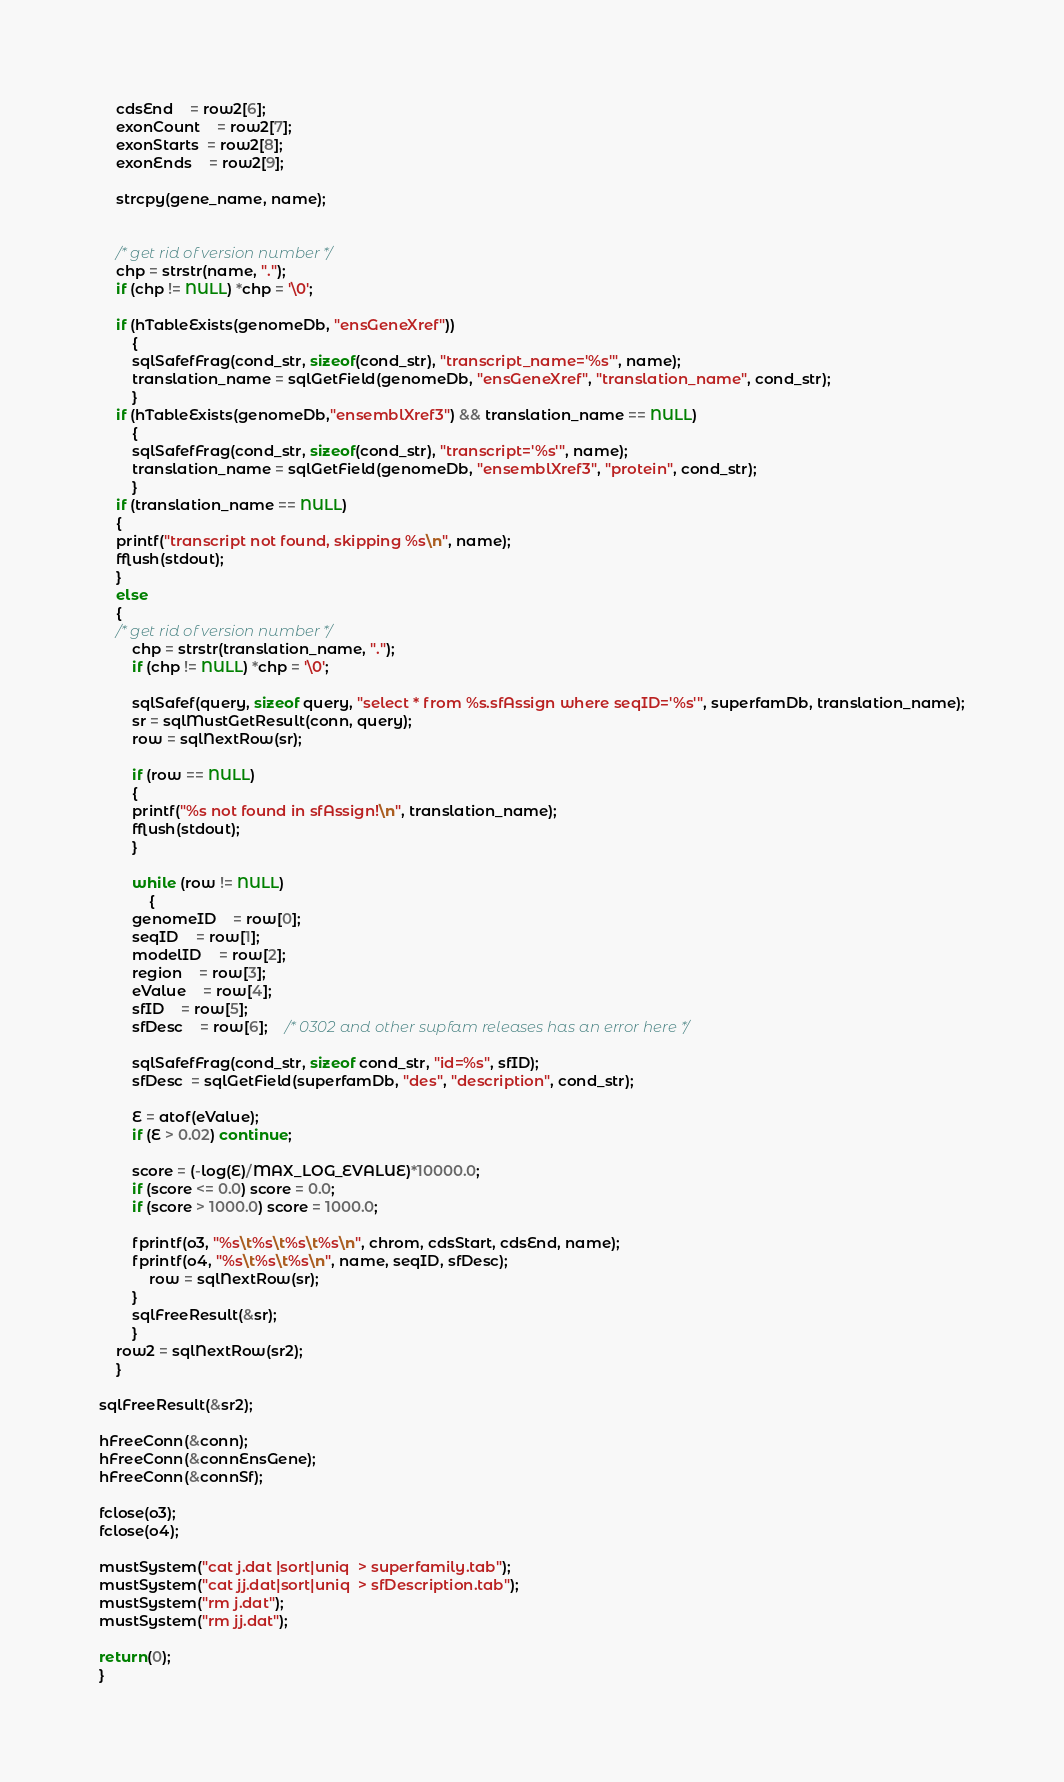Convert code to text. <code><loc_0><loc_0><loc_500><loc_500><_C_>    cdsEnd	= row2[6];
    exonCount 	= row2[7]; 
    exonStarts  = row2[8]; 
    exonEnds    = row2[9];	
			
    strcpy(gene_name, name);

    
    /* get rid of version number */
    chp = strstr(name, ".");
    if (chp != NULL) *chp = '\0';

    if (hTableExists(genomeDb, "ensGeneXref"))
        {
        sqlSafefFrag(cond_str, sizeof(cond_str), "transcript_name='%s'", name);
        translation_name = sqlGetField(genomeDb, "ensGeneXref", "translation_name", cond_str);
        }
    if (hTableExists(genomeDb,"ensemblXref3") && translation_name == NULL)
        {
        sqlSafefFrag(cond_str, sizeof(cond_str), "transcript='%s'", name);
        translation_name = sqlGetField(genomeDb, "ensemblXref3", "protein", cond_str);
        }
    if (translation_name == NULL) 
	{
	printf("transcript not found, skipping %s\n", name);
	fflush(stdout);
	}
    else
	{
	/* get rid of version number */
    	chp = strstr(translation_name, ".");
    	if (chp != NULL) *chp = '\0';

    	sqlSafef(query, sizeof query, "select * from %s.sfAssign where seqID='%s'", superfamDb, translation_name);
    	sr = sqlMustGetResult(conn, query);
    	row = sqlNextRow(sr);

    	if (row == NULL) 
	    {
	    printf("%s not found in sfAssign!\n", translation_name);
	    fflush(stdout);
	    }

    	while (row != NULL)
            {      
 	    genomeID	= row[0];
 	    seqID 	= row[1];
 	    modelID 	= row[2];
 	    region	= row[3];
 	    eValue	= row[4];
 	    sfID	= row[5];
 	    sfDesc	= row[6];	/* 0302 and other supfam releases has an error here */
		
	    sqlSafefFrag(cond_str, sizeof cond_str, "id=%s", sfID);
	    sfDesc  = sqlGetField(superfamDb, "des", "description", cond_str);

	    E = atof(eValue);
	    if (E > 0.02) continue;

	    score = (-log(E)/MAX_LOG_EVALUE)*10000.0;
	    if (score <= 0.0) score = 0.0;
	    if (score > 1000.0) score = 1000.0;
		
	    fprintf(o3, "%s\t%s\t%s\t%s\n", chrom, cdsStart, cdsEnd, name);
	    fprintf(o4, "%s\t%s\t%s\n", name, seqID, sfDesc);
            row = sqlNextRow(sr);
	    }
    	sqlFreeResult(&sr);
    	}
    row2 = sqlNextRow(sr2);
    }

sqlFreeResult(&sr2);

hFreeConn(&conn);
hFreeConn(&connEnsGene);
hFreeConn(&connSf);
    
fclose(o3);
fclose(o4);

mustSystem("cat j.dat |sort|uniq  > superfamily.tab");
mustSystem("cat jj.dat|sort|uniq  > sfDescription.tab");
mustSystem("rm j.dat");
mustSystem("rm jj.dat");
   
return(0);
}

</code> 